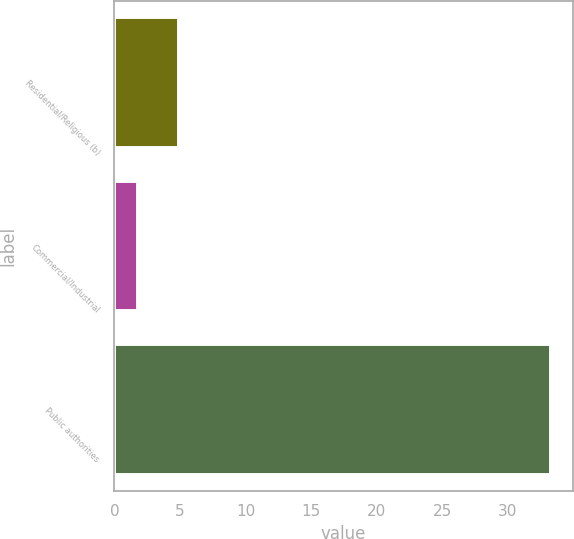Convert chart to OTSL. <chart><loc_0><loc_0><loc_500><loc_500><bar_chart><fcel>Residential/Religious (b)<fcel>Commercial/Industrial<fcel>Public authorities<nl><fcel>4.95<fcel>1.8<fcel>33.3<nl></chart> 